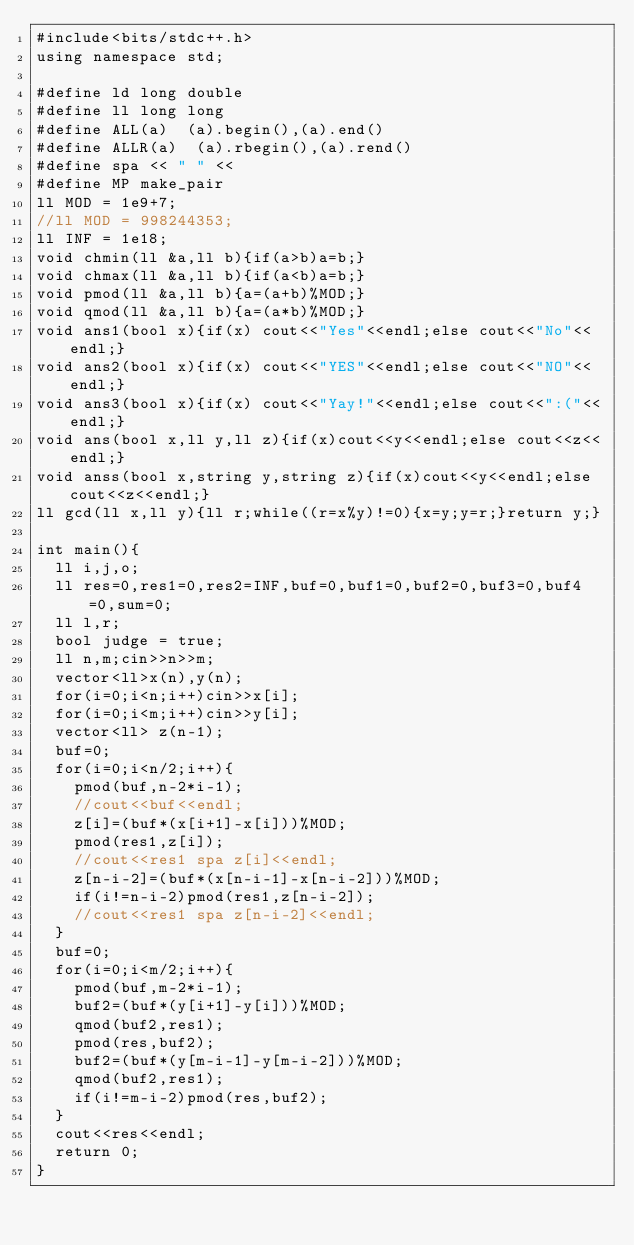<code> <loc_0><loc_0><loc_500><loc_500><_C++_>#include<bits/stdc++.h>
using namespace std;

#define ld long double
#define ll long long
#define ALL(a)  (a).begin(),(a).end()
#define ALLR(a)  (a).rbegin(),(a).rend()
#define spa << " " <<
#define MP make_pair
ll MOD = 1e9+7;
//ll MOD = 998244353;
ll INF = 1e18;
void chmin(ll &a,ll b){if(a>b)a=b;}
void chmax(ll &a,ll b){if(a<b)a=b;}
void pmod(ll &a,ll b){a=(a+b)%MOD;}
void qmod(ll &a,ll b){a=(a*b)%MOD;}
void ans1(bool x){if(x) cout<<"Yes"<<endl;else cout<<"No"<<endl;}
void ans2(bool x){if(x) cout<<"YES"<<endl;else cout<<"NO"<<endl;}
void ans3(bool x){if(x) cout<<"Yay!"<<endl;else cout<<":("<<endl;}
void ans(bool x,ll y,ll z){if(x)cout<<y<<endl;else cout<<z<<endl;}
void anss(bool x,string y,string z){if(x)cout<<y<<endl;else cout<<z<<endl;}   
ll gcd(ll x,ll y){ll r;while((r=x%y)!=0){x=y;y=r;}return y;}

int main(){
  ll i,j,o;
  ll res=0,res1=0,res2=INF,buf=0,buf1=0,buf2=0,buf3=0,buf4=0,sum=0;
  ll l,r;
  bool judge = true;
  ll n,m;cin>>n>>m;
  vector<ll>x(n),y(n);
  for(i=0;i<n;i++)cin>>x[i];
  for(i=0;i<m;i++)cin>>y[i];
  vector<ll> z(n-1);
  buf=0;
  for(i=0;i<n/2;i++){
    pmod(buf,n-2*i-1);
    //cout<<buf<<endl;
    z[i]=(buf*(x[i+1]-x[i]))%MOD;
    pmod(res1,z[i]);
    //cout<<res1 spa z[i]<<endl;
    z[n-i-2]=(buf*(x[n-i-1]-x[n-i-2]))%MOD;
    if(i!=n-i-2)pmod(res1,z[n-i-2]);
    //cout<<res1 spa z[n-i-2]<<endl;
  }
  buf=0;
  for(i=0;i<m/2;i++){
    pmod(buf,m-2*i-1);
    buf2=(buf*(y[i+1]-y[i]))%MOD;
    qmod(buf2,res1);
    pmod(res,buf2);
    buf2=(buf*(y[m-i-1]-y[m-i-2]))%MOD;
    qmod(buf2,res1);
    if(i!=m-i-2)pmod(res,buf2);
  }
  cout<<res<<endl;
  return 0;
}</code> 